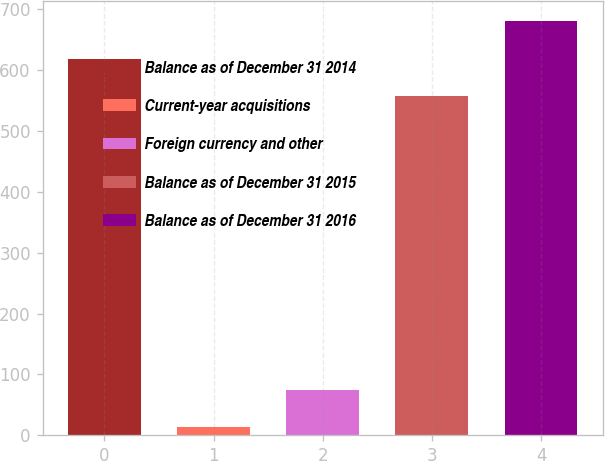Convert chart. <chart><loc_0><loc_0><loc_500><loc_500><bar_chart><fcel>Balance as of December 31 2014<fcel>Current-year acquisitions<fcel>Foreign currency and other<fcel>Balance as of December 31 2015<fcel>Balance as of December 31 2016<nl><fcel>618.84<fcel>13.2<fcel>74.94<fcel>557.1<fcel>680.58<nl></chart> 